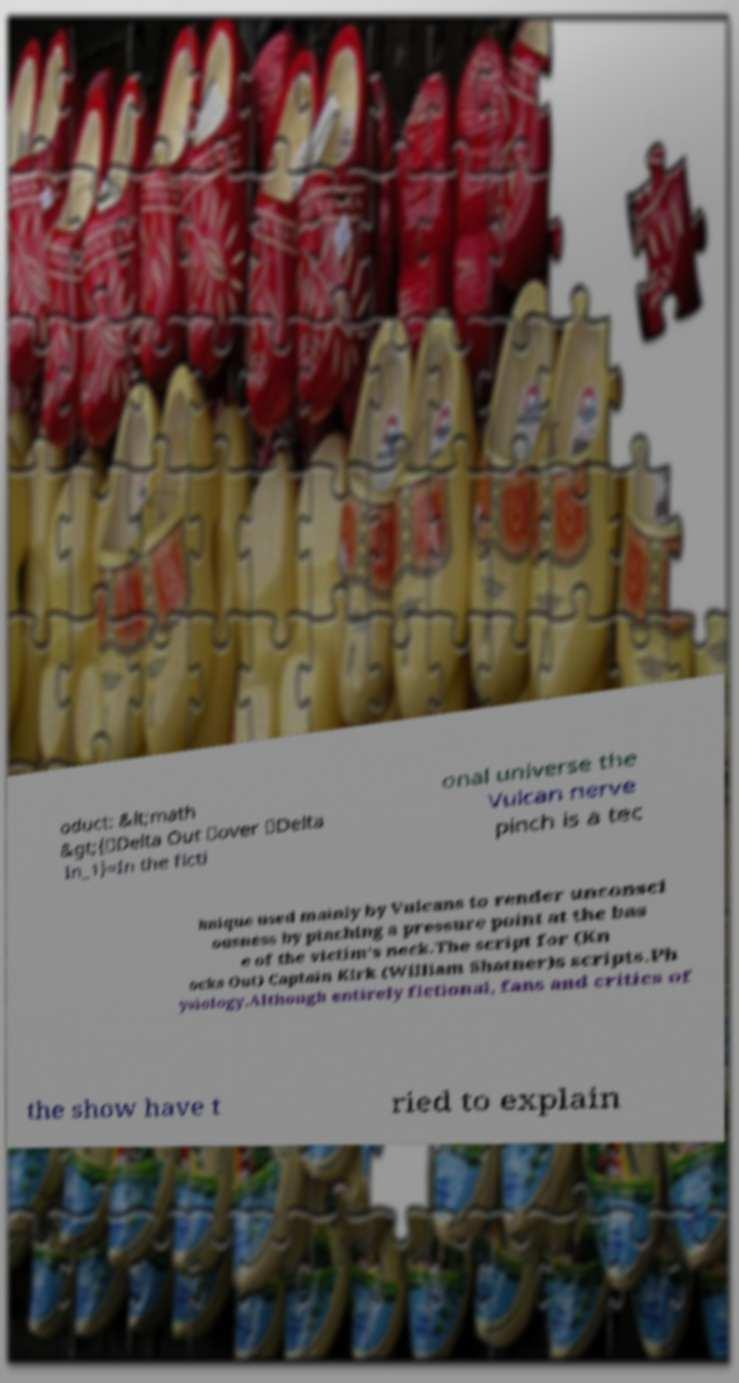Could you assist in decoding the text presented in this image and type it out clearly? oduct: &lt;math &gt;{\Delta Out \over \Delta In_1}=In the ficti onal universe the Vulcan nerve pinch is a tec hnique used mainly by Vulcans to render unconsci ousness by pinching a pressure point at the bas e of the victim's neck.The script for (Kn ocks Out) Captain Kirk (William Shatner)s scripts.Ph ysiology.Although entirely fictional, fans and critics of the show have t ried to explain 